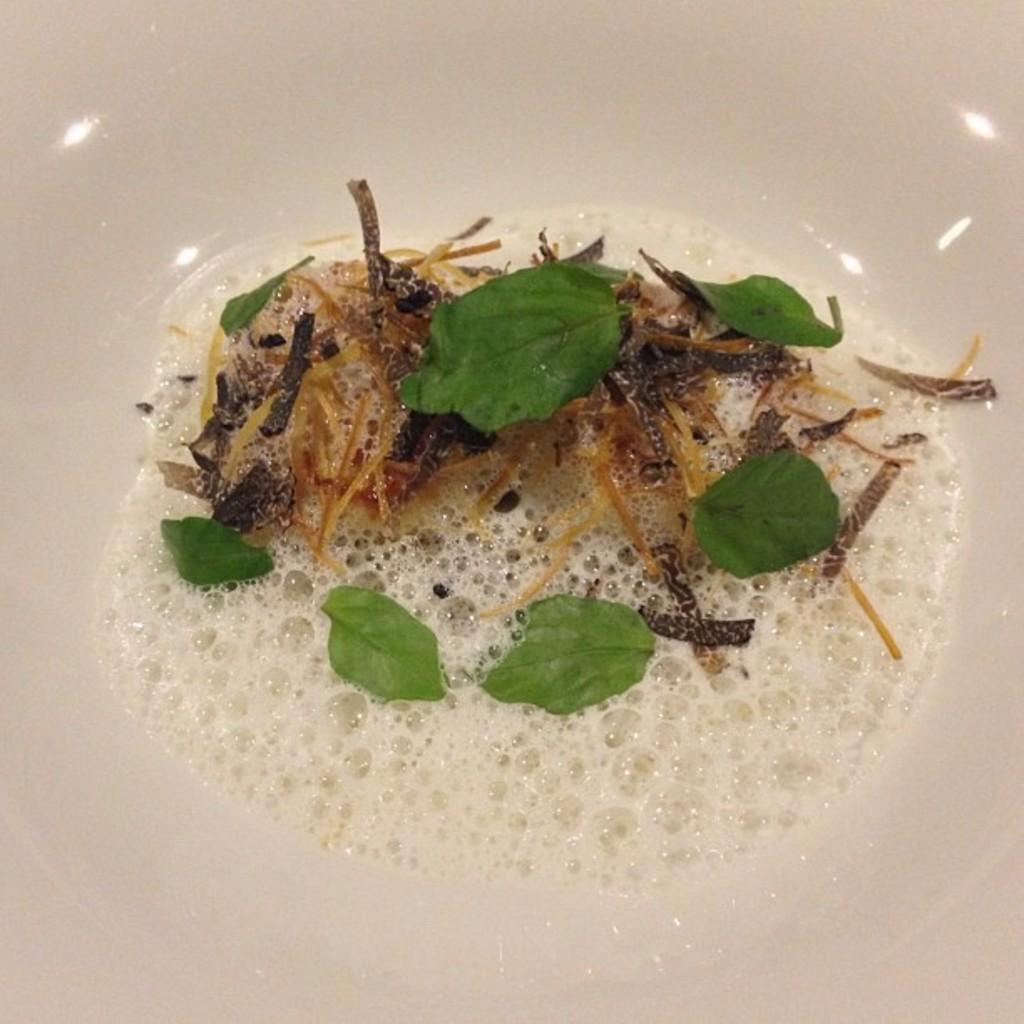What is the main color of the object in the image? The main color of the object in the image is white. What type of vegetation is on the white object? The white object has green leaves on it. What else can be seen on the white object? There are other things on the white object. What can be seen reflecting on the top side of the image? There is a reflection of lights on the top side of the image. What appliance is generating the idea in the image? There is no appliance generating an idea in the image, nor is there any indication of an act being performed. 